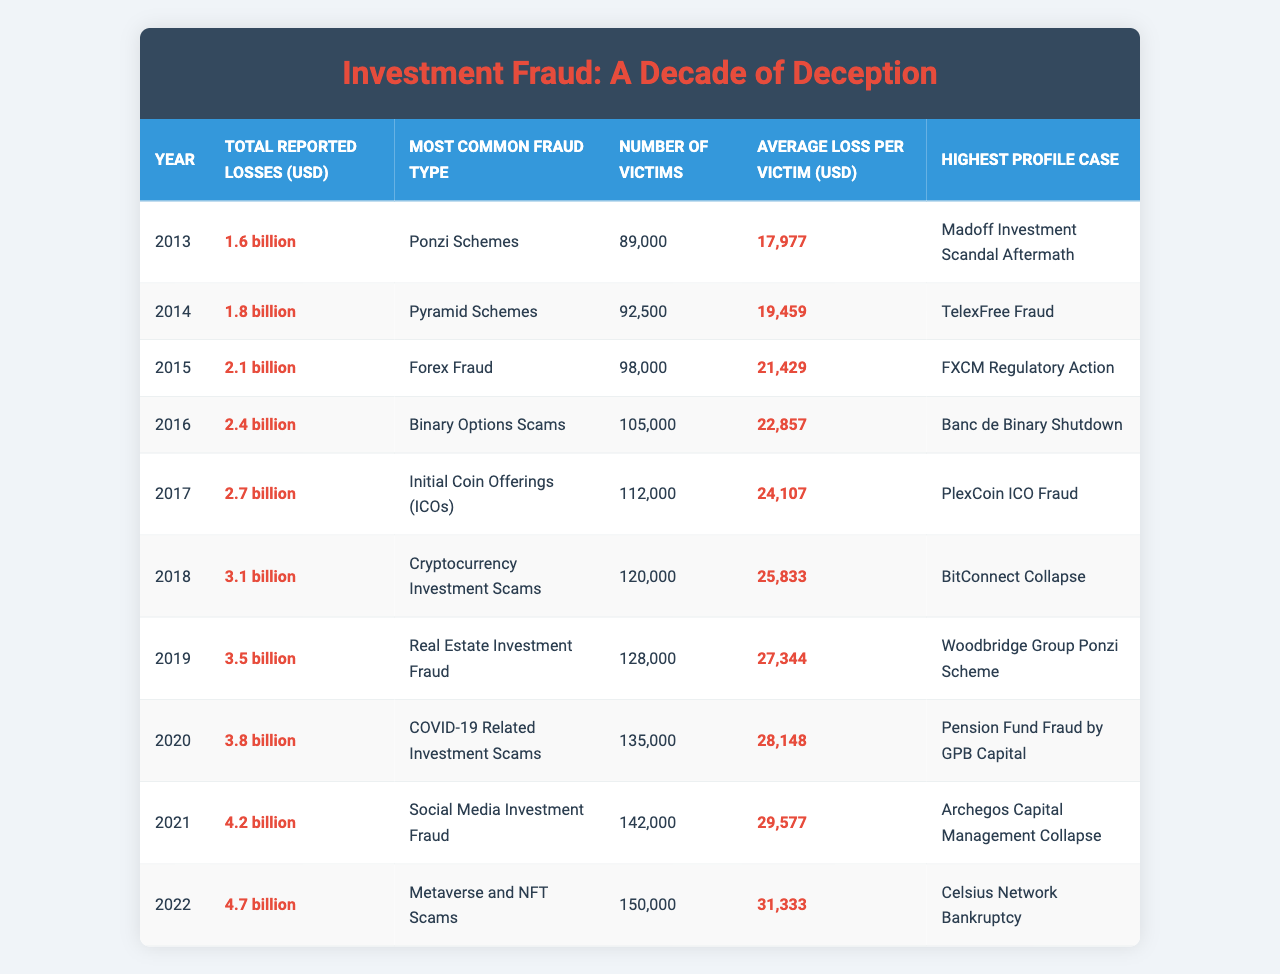What was the total reported loss in 2014? The table states that the total reported losses in 2014 were 1.8 billion USD as indicated in the corresponding row for that year.
Answer: 1.8 billion Which fraud type was most common in 2019? According to the table, the most common fraud type reported in 2019 was Real Estate Investment Fraud, as seen in that year's row.
Answer: Real Estate Investment Fraud What is the average loss per victim in 2022? The average loss per victim for the year 2022 is found in its row, which indicates it was 31,333 USD.
Answer: 31,333 USD How many total victims were reported across all years provided? To find the total number of victims, you sum the number of victims from all the years: 89,000 + 92,500 + 98,000 + 105,000 + 112,000 + 120,000 + 128,000 + 135,000 + 142,000 + 150,000 = 1,221,500.
Answer: 1,221,500 Does the highest profile case in 2021 involve cryptocurrency? The highest profile case in 2021 was the "Archegos Capital Management Collapse," which does not involve cryptocurrency. The table can be referred to for confirmation.
Answer: No What was the increase in total reported losses from 2013 to 2022? The total reported losses in 2013 were 1.6 billion, and in 2022 they were 4.7 billion. The increase is calculated as 4.7 billion - 1.6 billion = 3.1 billion.
Answer: 3.1 billion Which year had the highest average loss per victim, and what was that amount? Looking through the average losses per victim from each year listed, 2022 has the highest average loss at 31,333 USD.
Answer: 2022; 31,333 USD Was there a year when the most common fraud type was a Ponzi scheme after 2013? The table shows that the most common fraud type was a Ponzi scheme only in 2013; subsequent years have different fraud types listed.
Answer: No How many victims were there in total from the years 2014 to 2016? The total number of victims from 2014 to 2016 can be calculated by summing (92,500 + 98,000 + 105,000) = 295,500.
Answer: 295,500 Which year had the smallest average loss per victim? By examining the average loss per victim for each year, the year 2013 shows the smallest average loss at 17,977 USD.
Answer: 2013; 17,977 USD 